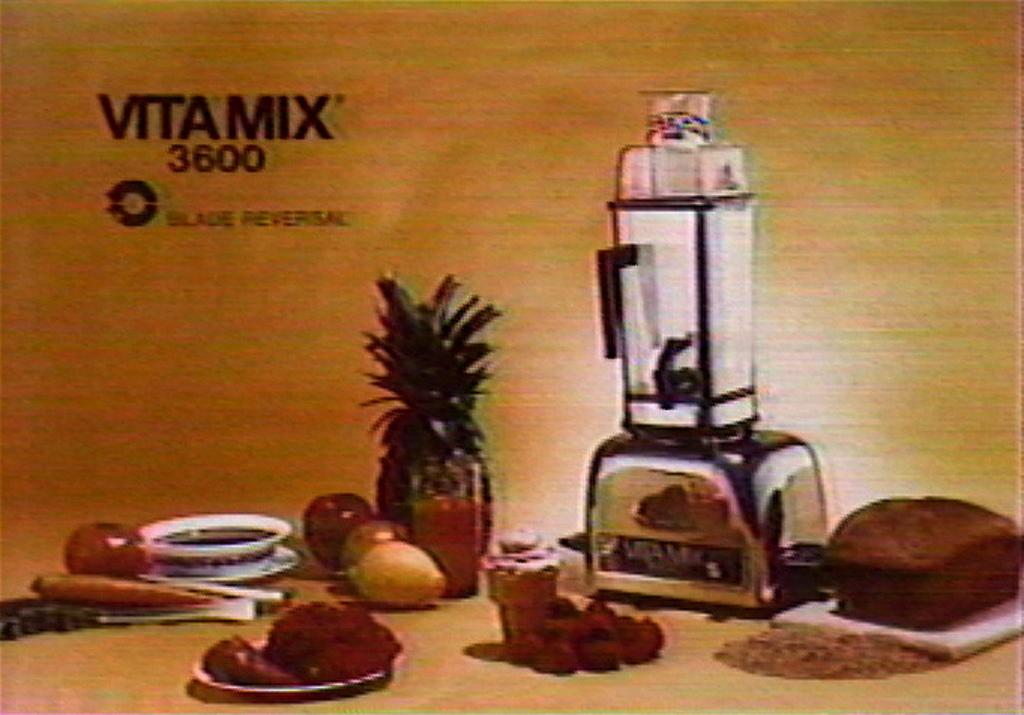Provide a one-sentence caption for the provided image. A picture of a blender called Vita Mix. 